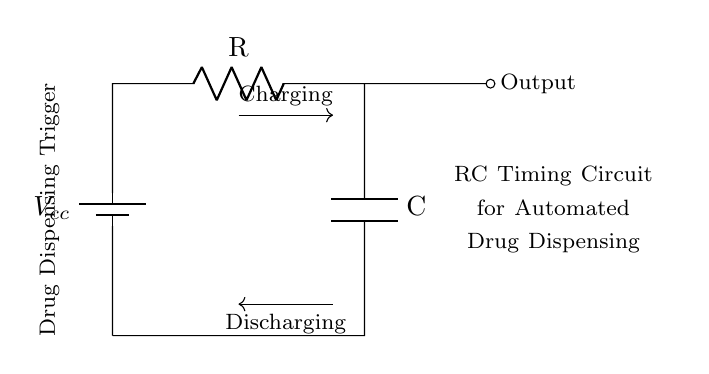What components are present in this circuit? This circuit includes a battery, a resistor, and a capacitor, as indicated by the symbols in the diagram. The battery is on the left, the resistor is next to the battery, and the capacitor is at the bottom of the circuit.
Answer: Battery, Resistor, Capacitor What is the role of the resistor in this circuit? The resistor limits the current flowing into the capacitor during the charging phase, which controls the time it takes for the capacitor to charge up to a certain voltage level. This affects the timing in the circuit.
Answer: Current Limiting What is the significance of the output connection in the circuit? The output connection indicates where the voltage across the capacitor can be observed, which is used as a trigger for the drug dispensing action. This output voltage changes as the capacitor charges and discharges.
Answer: Triggering Device How does the capacitor discharge in this circuit? When the circuit reaches a certain voltage threshold, the capacitor begins to discharge, allowing the stored electrical energy to be released into the system, which triggers the drug dispensing mechanism. This is evident from the labeling of discharging in the diagram.
Answer: Releases Stored Energy What is the function of the drug dispensing trigger mentioned in the diagram? The drug dispensing trigger is designed to respond to the voltage changes at the output, indicating when the circuit is ready to dispense medication, controlled by the charge state of the capacitor. This is critical for timing in automated dispensing.
Answer: Activates Drug Dispensing What determines the timing characteristics of this RC circuit? The timing characteristics of the RC circuit are determined by the values of the resistor and capacitor. The time constant, which dictates how quickly the capacitor charges or discharges, is calculated using the formula tau equals R multiplied by C.
Answer: Resistor and Capacitor Values 